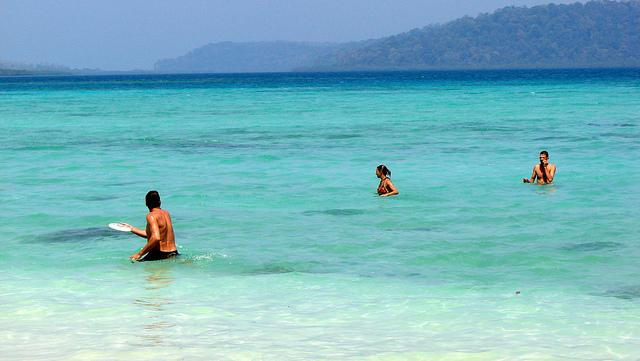What is the man in deep water about to catch? frisbee 